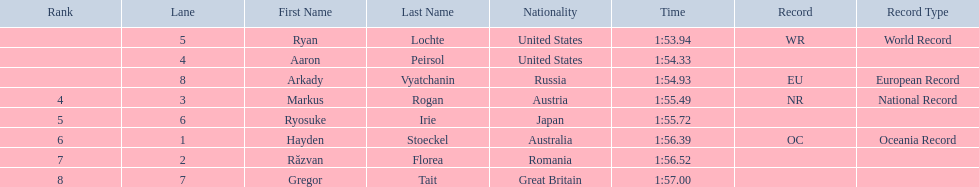Who are the swimmers? Ryan Lochte, Aaron Peirsol, Arkady Vyatchanin, Markus Rogan, Ryosuke Irie, Hayden Stoeckel, Răzvan Florea, Gregor Tait. What is ryosuke irie's time? 1:55.72. 